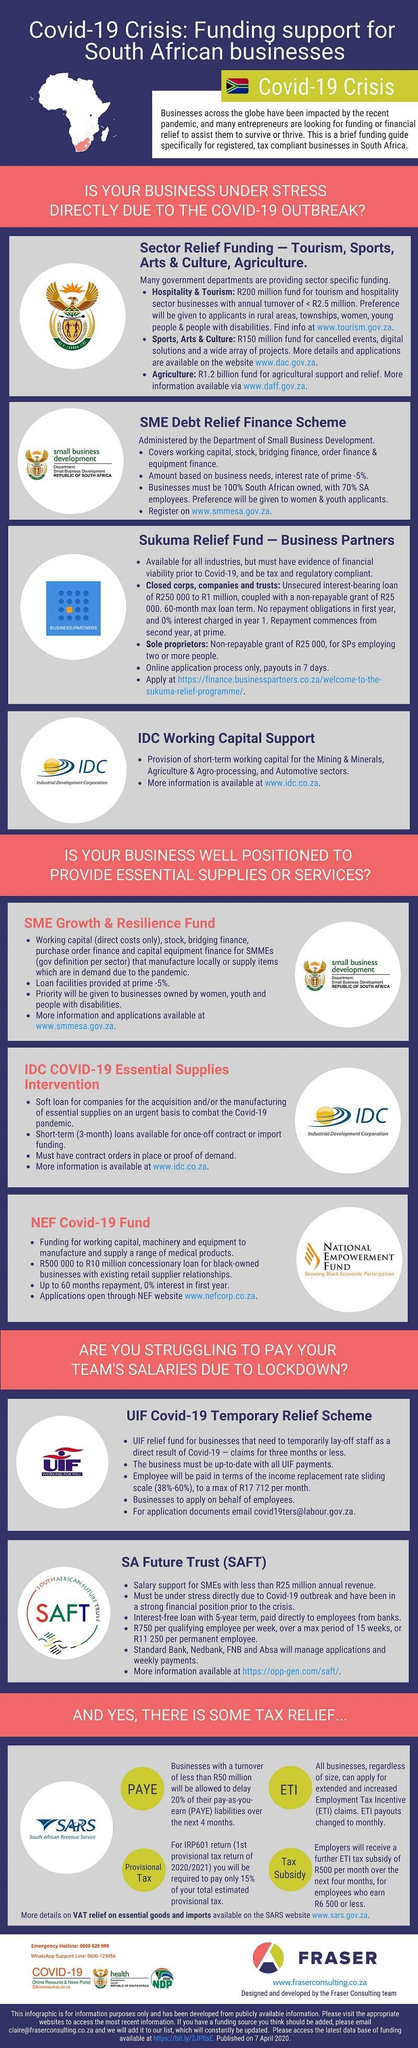How many points are under the heading "SME Growth & Resilience Fund"?
Answer the question with a short phrase. 4 How many points are under the heading "IDC Working Capital Support"? 2 